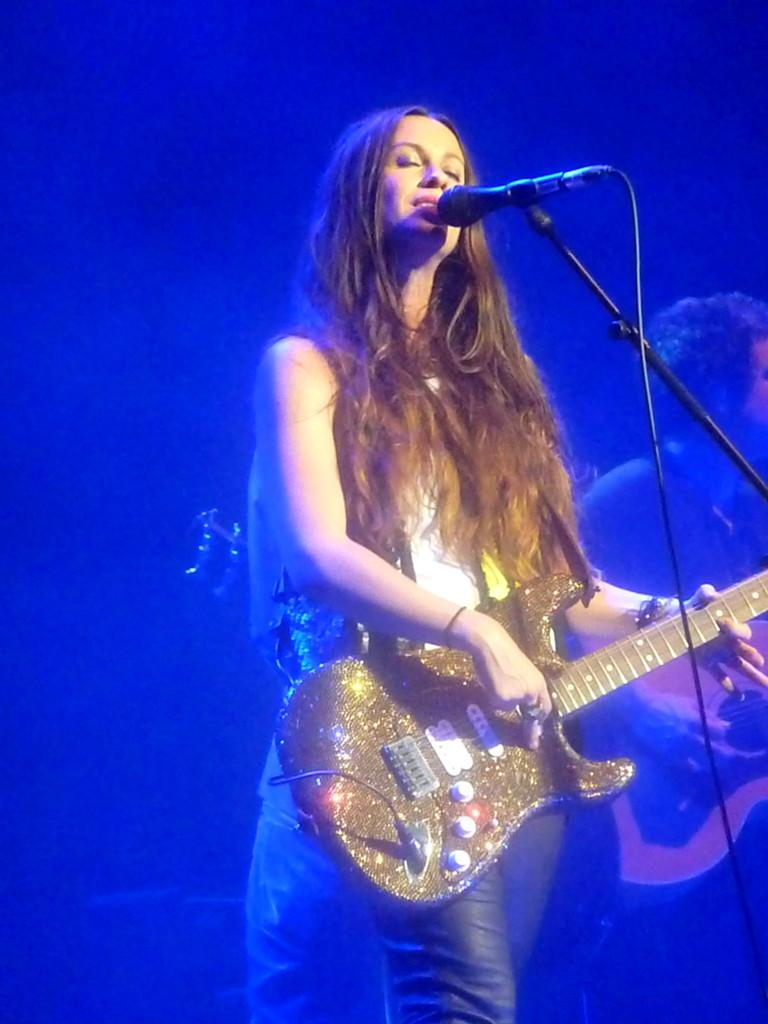What is the woman in the image doing? The woman is standing in front of a microphone and playing a guitar. Can you describe the man in the image? The man in the image is also holding a guitar. What is the color of the background in the image? The background of the image is predominantly blue. What type of owl can be seen flying in the background of the image? There is no owl present in the image; the background is predominantly blue. Can you explain the magic spell the woman is casting on the microphone? There is no mention of magic or spells in the image; the woman is simply playing a guitar in front of a microphone. 